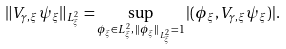Convert formula to latex. <formula><loc_0><loc_0><loc_500><loc_500>\| V _ { \gamma , \xi } \psi _ { \xi } \| _ { L _ { \xi } ^ { 2 } } = \sup _ { \phi _ { \xi } \in L _ { \xi } ^ { 2 } , \, \| \phi _ { \xi } \| _ { L ^ { 2 } _ { \xi } } = 1 } | ( \phi _ { \xi } , V _ { \gamma , \xi } \psi _ { \xi } ) | .</formula> 